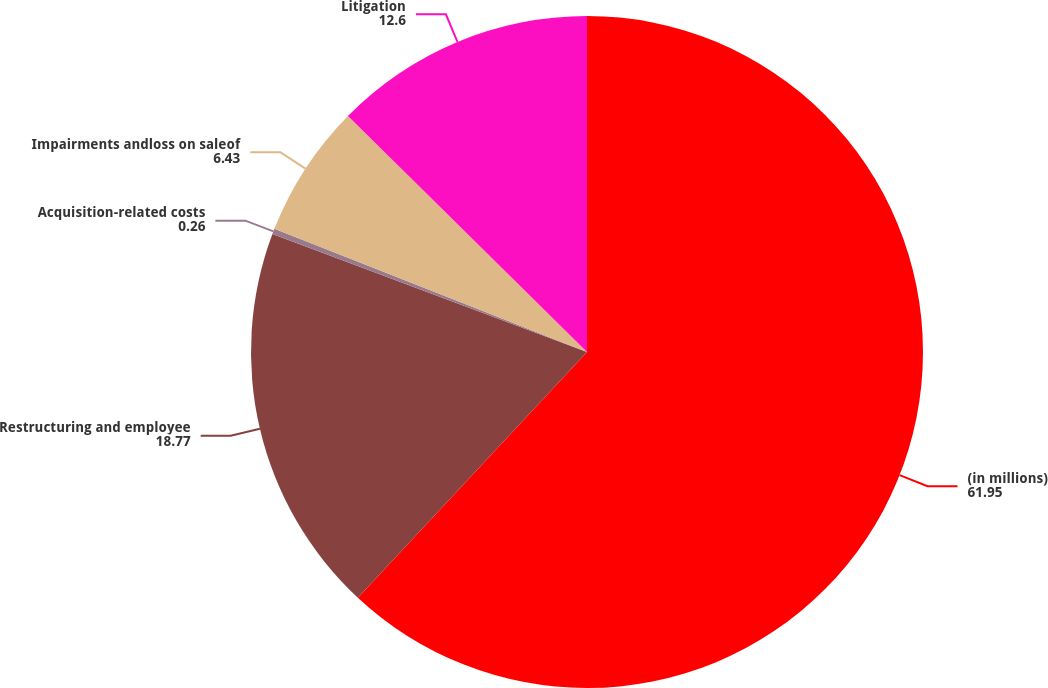<chart> <loc_0><loc_0><loc_500><loc_500><pie_chart><fcel>(in millions)<fcel>Restructuring and employee<fcel>Acquisition-related costs<fcel>Impairments andloss on saleof<fcel>Litigation<nl><fcel>61.95%<fcel>18.77%<fcel>0.26%<fcel>6.43%<fcel>12.6%<nl></chart> 